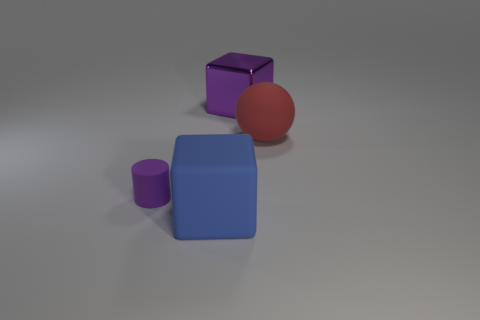Is the color of the tiny object the same as the shiny thing?
Your answer should be very brief. Yes. Are there any tiny purple cylinders that have the same material as the large red sphere?
Provide a succinct answer. Yes. What is the material of the purple object that is behind the matte sphere?
Offer a terse response. Metal. What is the big purple object made of?
Provide a short and direct response. Metal. Does the cube that is in front of the small purple cylinder have the same material as the big red ball?
Offer a very short reply. Yes. Is the number of large blue cubes that are behind the big blue rubber cube less than the number of purple blocks?
Make the answer very short. Yes. What is the color of the metal block that is the same size as the red ball?
Make the answer very short. Purple. What number of other objects have the same shape as the blue matte object?
Your answer should be very brief. 1. There is a large object that is in front of the purple cylinder; what is its color?
Offer a terse response. Blue. How many metallic objects are either cylinders or cyan balls?
Offer a terse response. 0. 